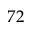<formula> <loc_0><loc_0><loc_500><loc_500>7 2</formula> 